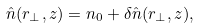<formula> <loc_0><loc_0><loc_500><loc_500>\hat { n } ( { r } _ { \perp } , z ) = n _ { 0 } + \delta \hat { n } ( { r } _ { \perp } , z ) ,</formula> 